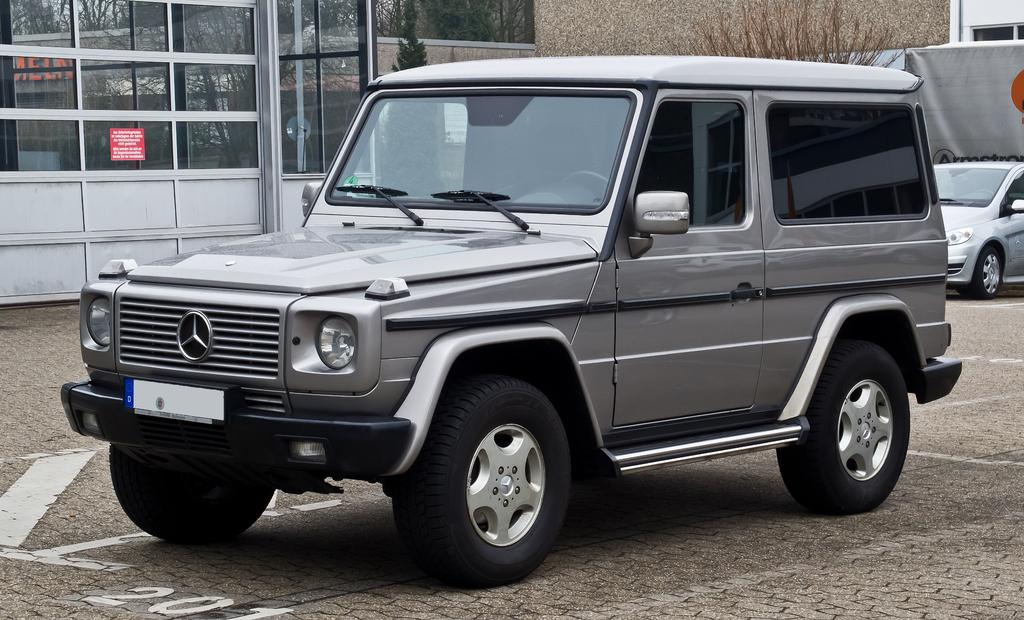What type of objects can be seen in the image? There are vehicles in the image. Where are the vehicles located? The vehicles are on a pavement. What else can be seen in the image besides the vehicles? There are windows visible in the image. What type of structure is present in the image? There is a wall in the image. What type of pickle is being served at the restaurant in the image? There is no restaurant or pickle present in the image; it features vehicles on a pavement with windows and a wall. 